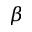Convert formula to latex. <formula><loc_0><loc_0><loc_500><loc_500>\beta</formula> 